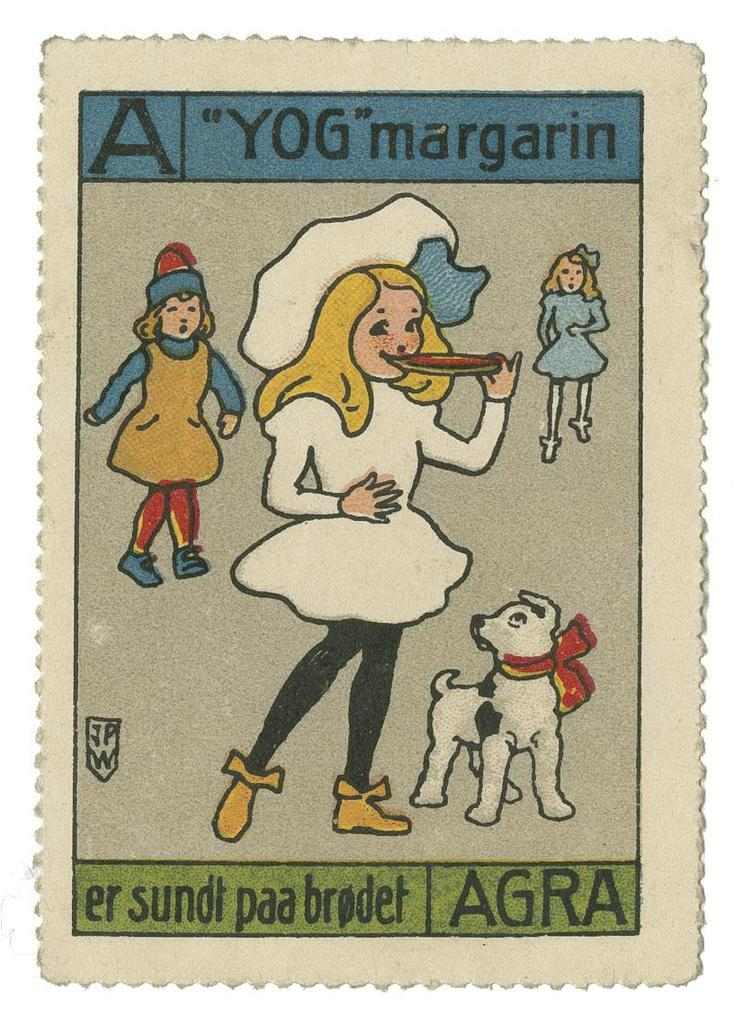What type of characters are depicted in the picture? There are cartoon images of girls, a woman, and a dog in the picture. Where can the text be found in the picture? There is text at the top and bottom of the picture. What is the subject matter of the cartoon images? The cartoon images depict girls, a woman, and a dog. How many boys are sitting on the seat in the picture? There are no boys or seats present in the image. Is there an oven visible in the picture? There is no oven present in the image. 